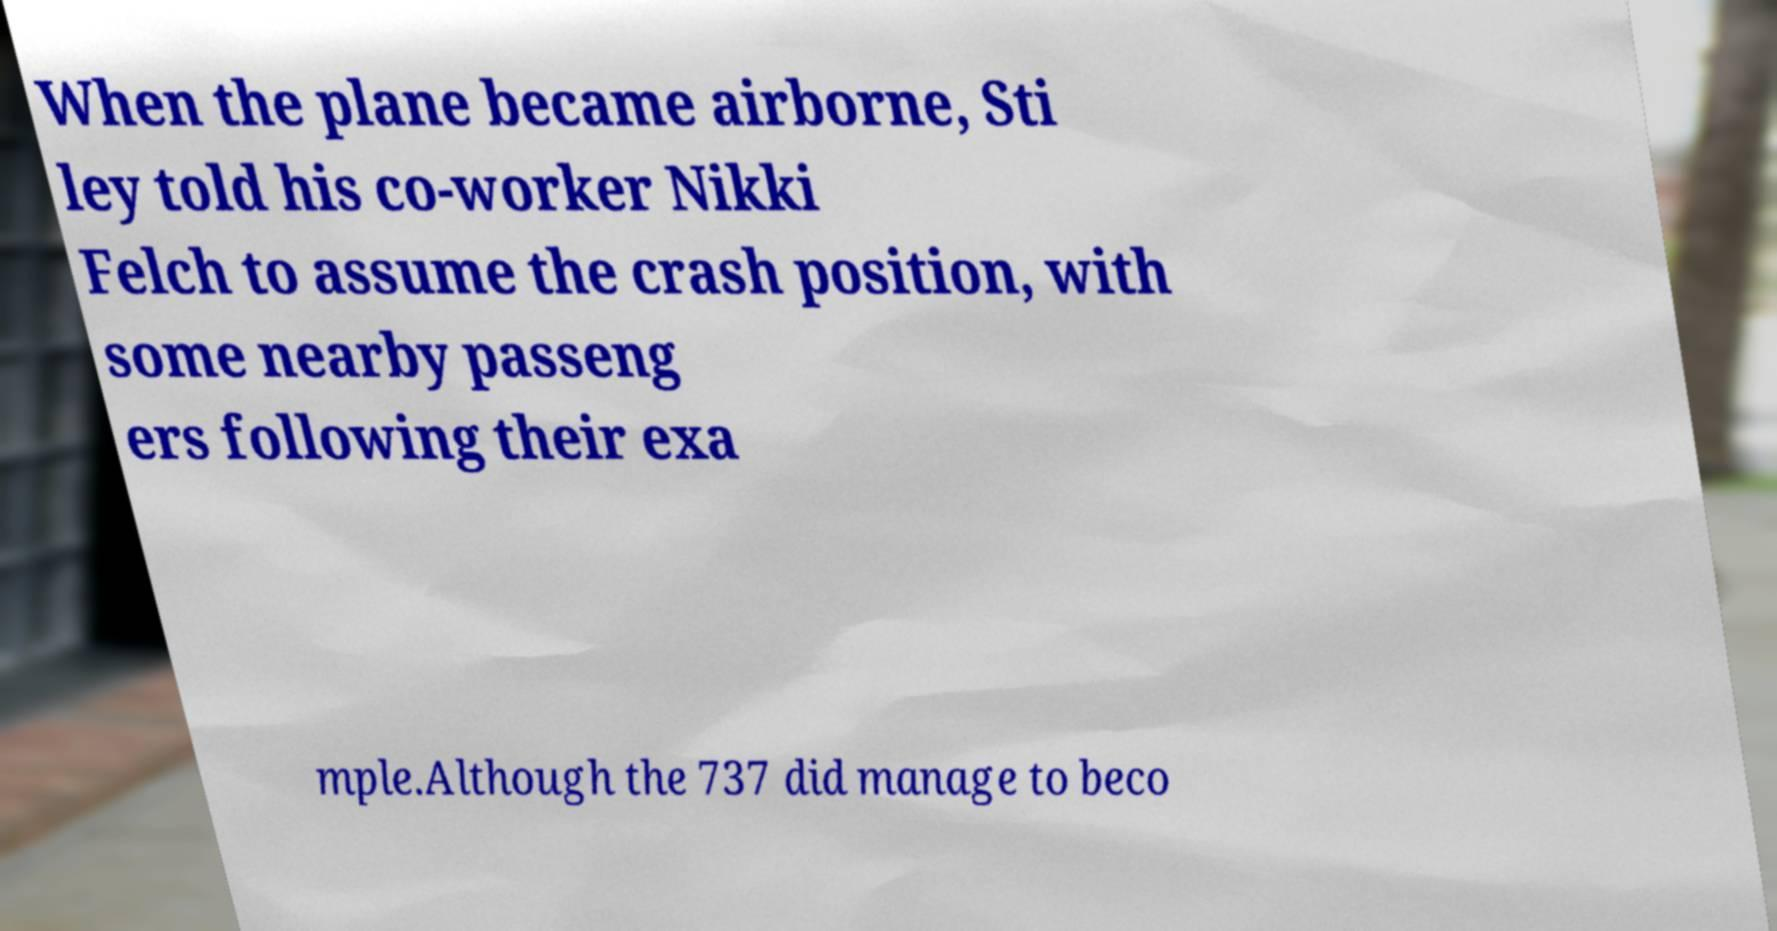What messages or text are displayed in this image? I need them in a readable, typed format. When the plane became airborne, Sti ley told his co-worker Nikki Felch to assume the crash position, with some nearby passeng ers following their exa mple.Although the 737 did manage to beco 